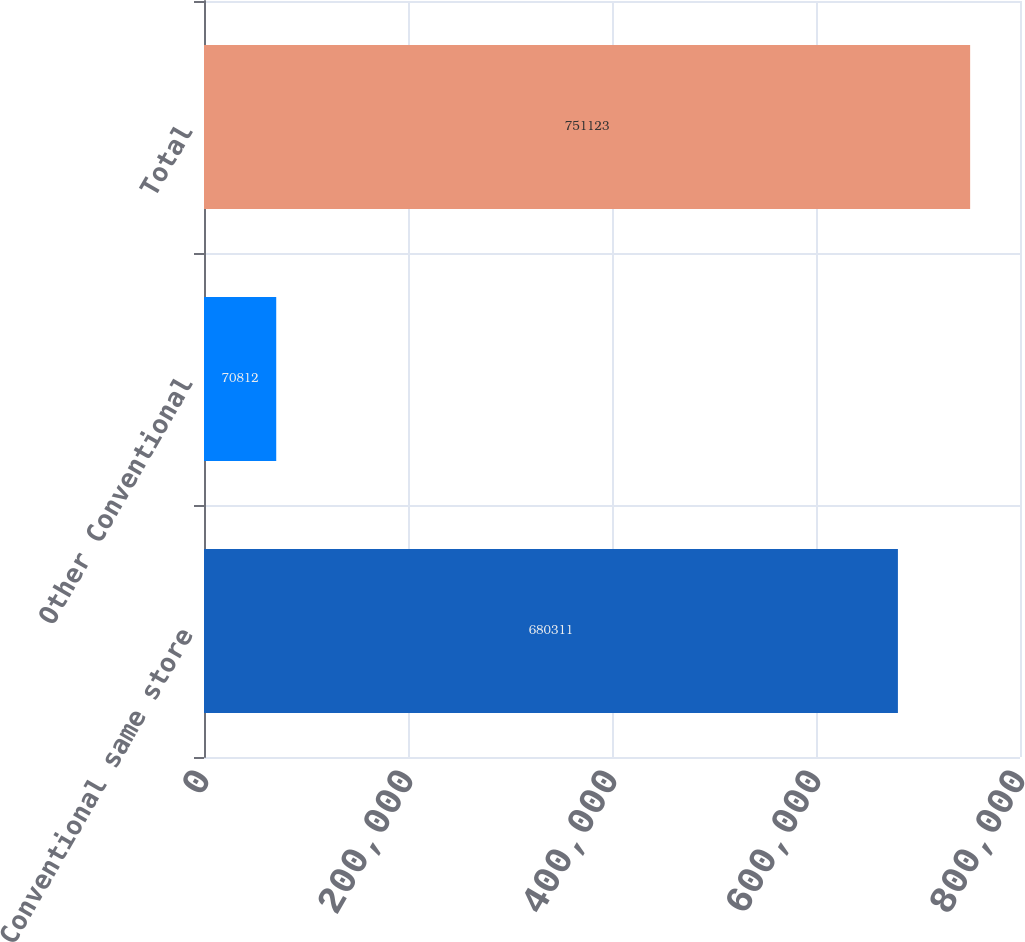<chart> <loc_0><loc_0><loc_500><loc_500><bar_chart><fcel>Conventional same store<fcel>Other Conventional<fcel>Total<nl><fcel>680311<fcel>70812<fcel>751123<nl></chart> 